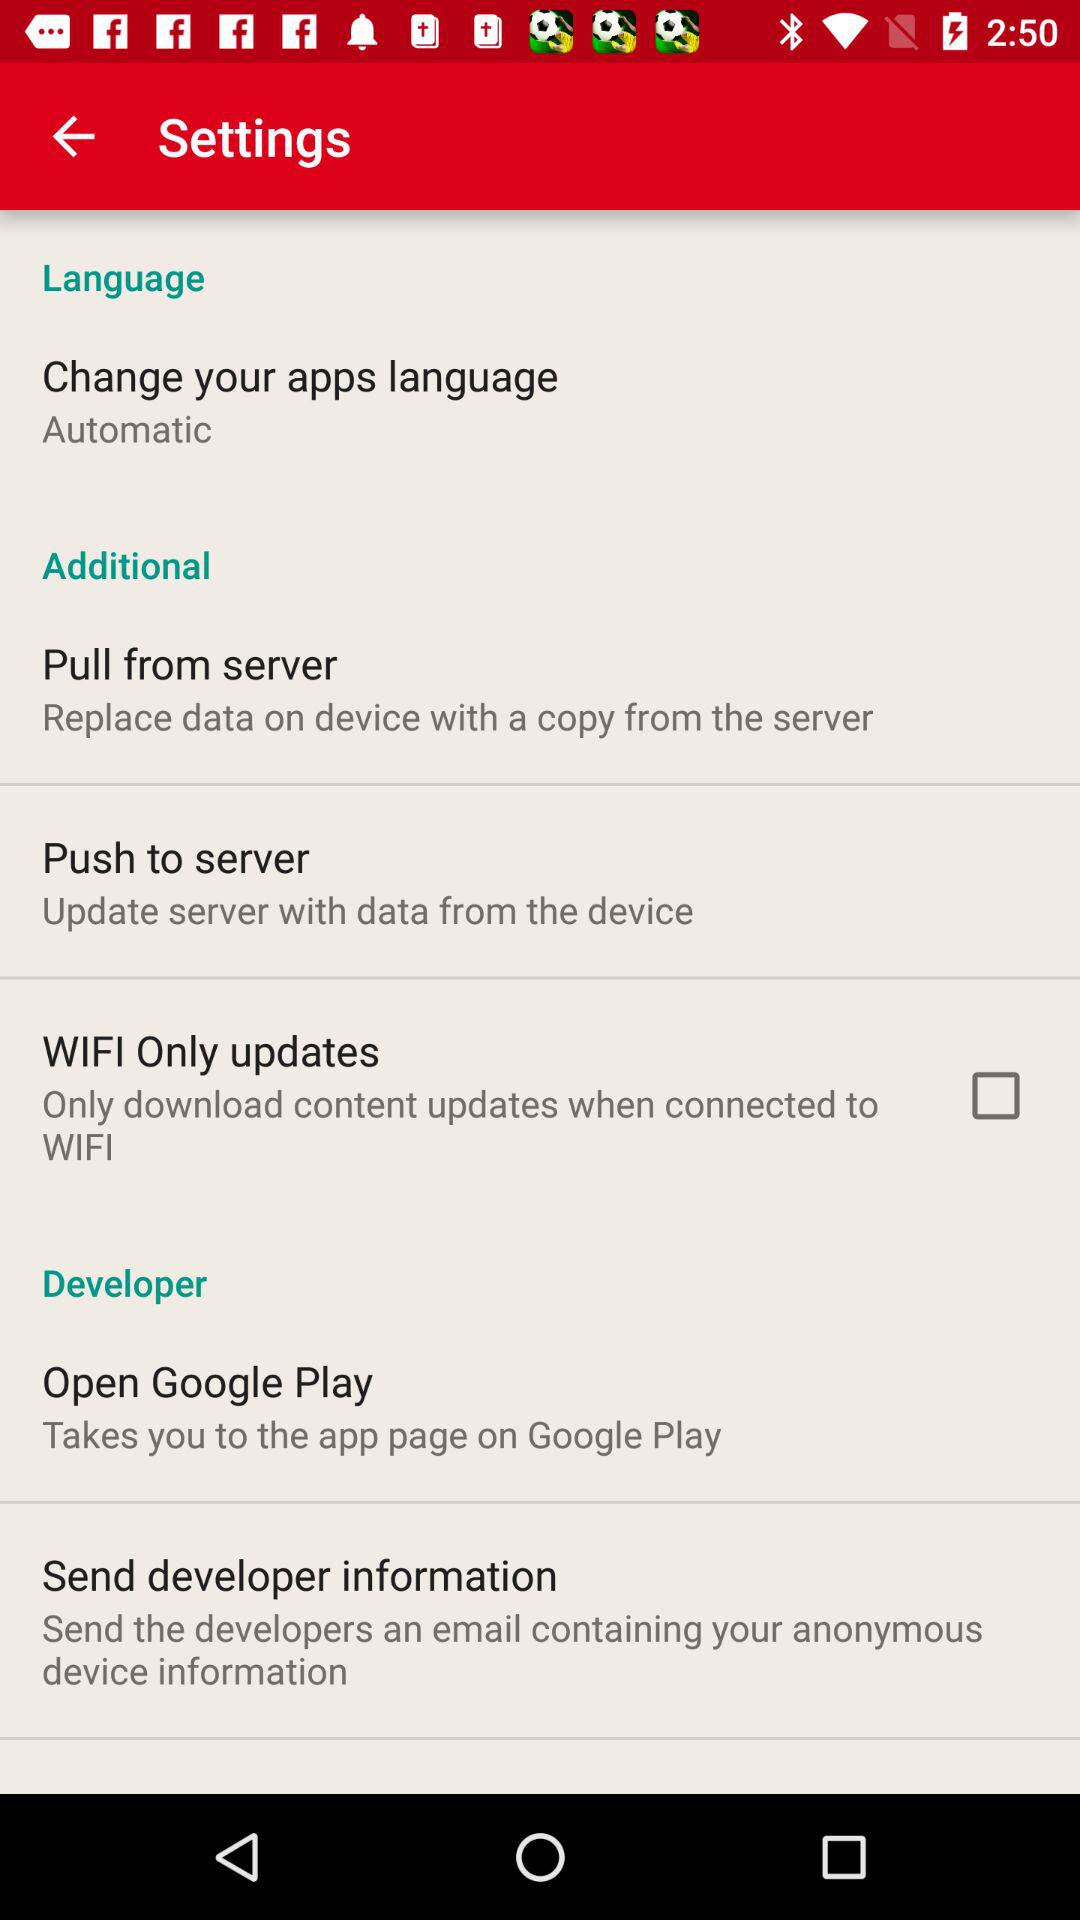What is the status of "WIFI Only updates"? The status is "off". 